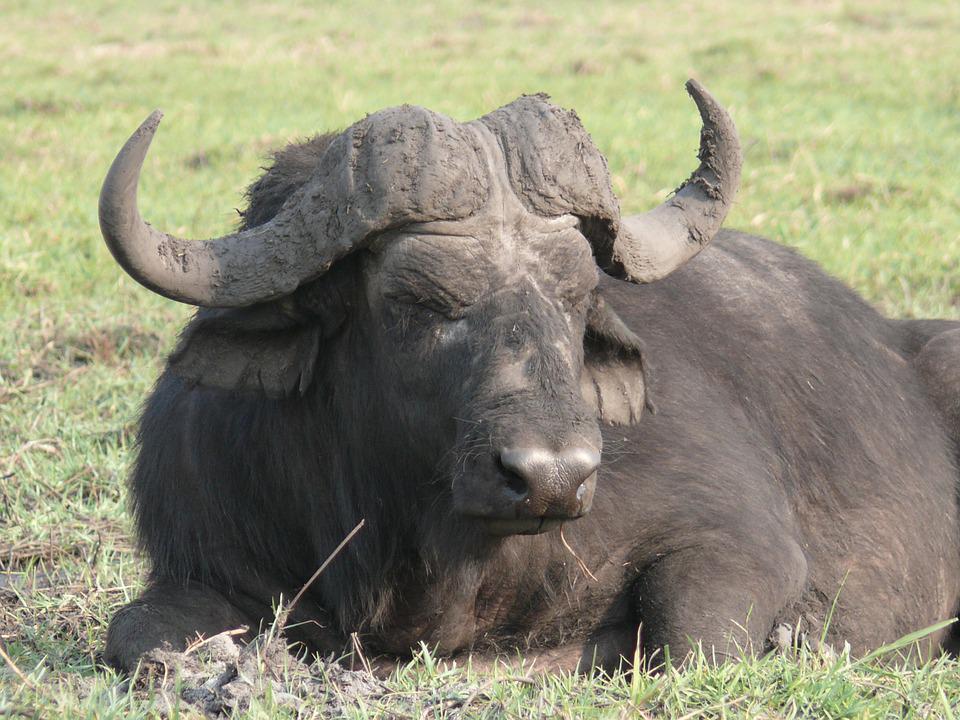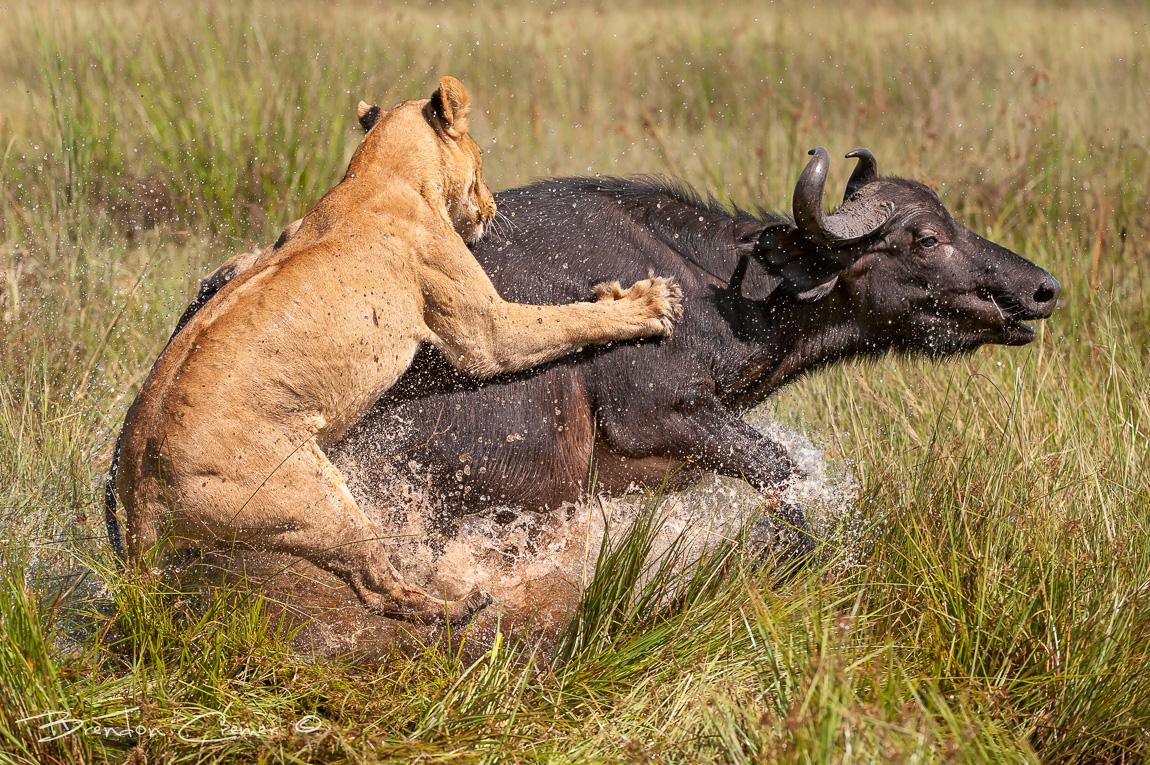The first image is the image on the left, the second image is the image on the right. Given the left and right images, does the statement "Two water buffalos are standing in water." hold true? Answer yes or no. No. The first image is the image on the left, the second image is the image on the right. For the images displayed, is the sentence "An image contains a water buffalo standing in water." factually correct? Answer yes or no. No. 